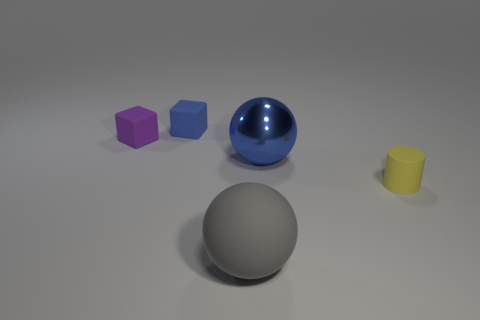Add 1 tiny rubber objects. How many objects exist? 6 Subtract all balls. How many objects are left? 3 Add 5 rubber objects. How many rubber objects exist? 9 Subtract 0 red blocks. How many objects are left? 5 Subtract all tiny yellow cylinders. Subtract all large red metallic cubes. How many objects are left? 4 Add 2 blue objects. How many blue objects are left? 4 